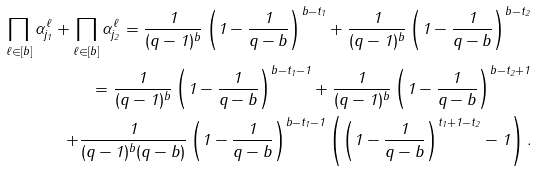Convert formula to latex. <formula><loc_0><loc_0><loc_500><loc_500>\prod _ { \ell \in [ b ] } \alpha ^ { \ell } _ { j _ { 1 } } + \prod _ { \ell \in [ b ] } \alpha ^ { \ell } _ { j _ { 2 } } = \frac { 1 } { ( q - 1 ) ^ { b } } \left ( 1 - \frac { 1 } { q - b } \right ) ^ { b - t _ { 1 } } + \frac { 1 } { ( q - 1 ) ^ { b } } \left ( 1 - \frac { 1 } { q - b } \right ) ^ { b - t _ { 2 } } \\ = \frac { 1 } { ( q - 1 ) ^ { b } } \left ( 1 - \frac { 1 } { q - b } \right ) ^ { b - t _ { 1 } - 1 } + \frac { 1 } { ( q - 1 ) ^ { b } } \left ( 1 - \frac { 1 } { q - b } \right ) ^ { b - t _ { 2 } + 1 } \\ + \frac { 1 } { ( q - 1 ) ^ { b } ( q - b ) } \left ( 1 - \frac { 1 } { q - b } \right ) ^ { b - t _ { 1 } - 1 } \left ( \left ( 1 - \frac { 1 } { q - b } \right ) ^ { t _ { 1 } + 1 - t _ { 2 } } - 1 \right ) .</formula> 